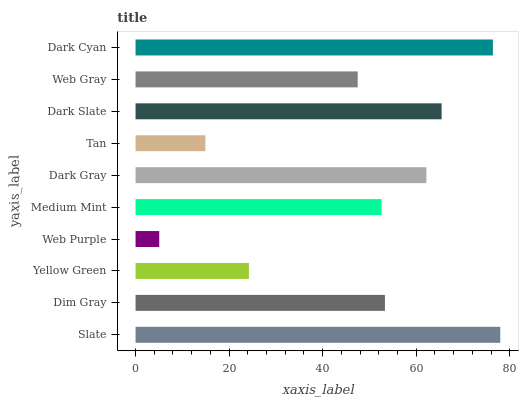Is Web Purple the minimum?
Answer yes or no. Yes. Is Slate the maximum?
Answer yes or no. Yes. Is Dim Gray the minimum?
Answer yes or no. No. Is Dim Gray the maximum?
Answer yes or no. No. Is Slate greater than Dim Gray?
Answer yes or no. Yes. Is Dim Gray less than Slate?
Answer yes or no. Yes. Is Dim Gray greater than Slate?
Answer yes or no. No. Is Slate less than Dim Gray?
Answer yes or no. No. Is Dim Gray the high median?
Answer yes or no. Yes. Is Medium Mint the low median?
Answer yes or no. Yes. Is Web Purple the high median?
Answer yes or no. No. Is Yellow Green the low median?
Answer yes or no. No. 